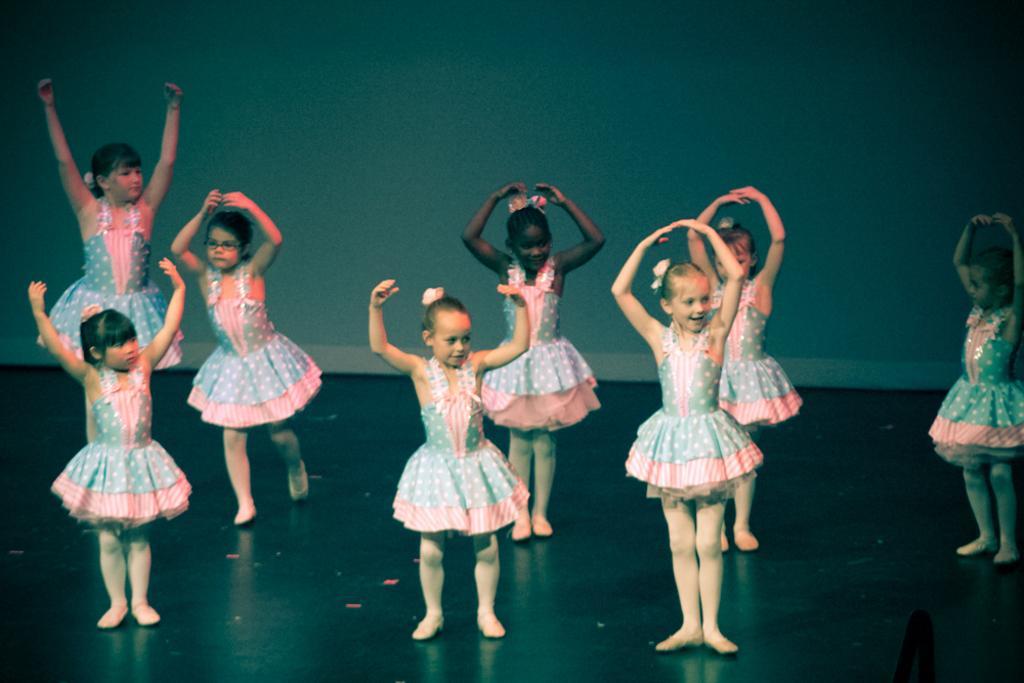Please provide a concise description of this image. Girls are dancing by raising their hands. They are wearing frocks. 